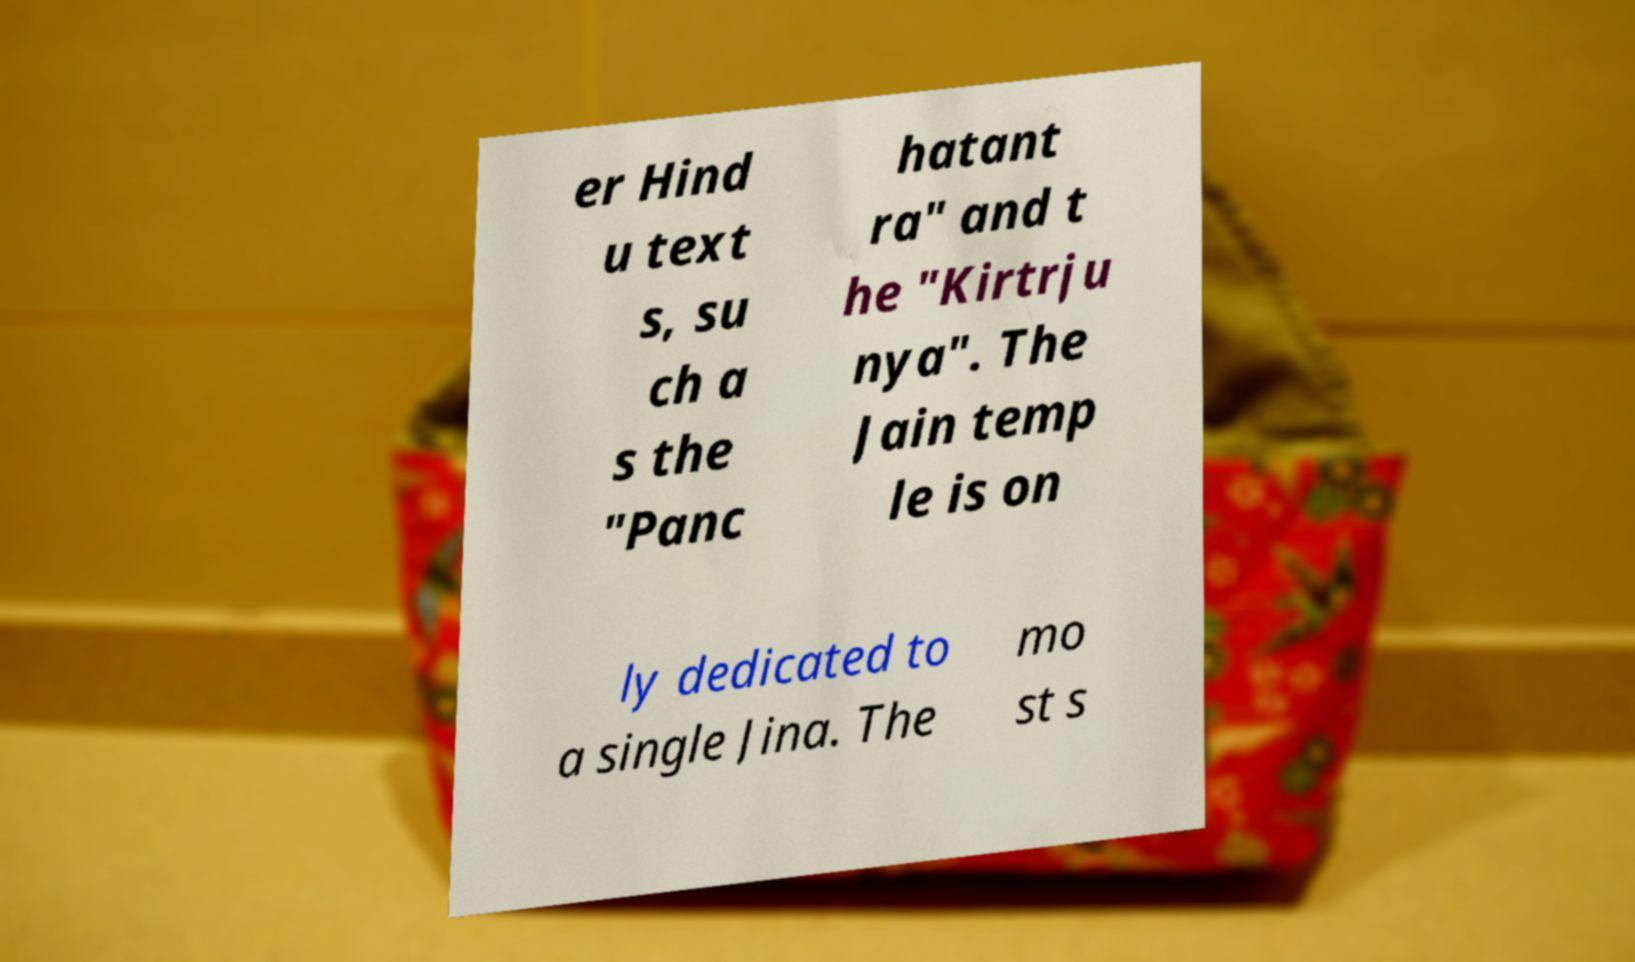Could you extract and type out the text from this image? er Hind u text s, su ch a s the "Panc hatant ra" and t he "Kirtrju nya". The Jain temp le is on ly dedicated to a single Jina. The mo st s 